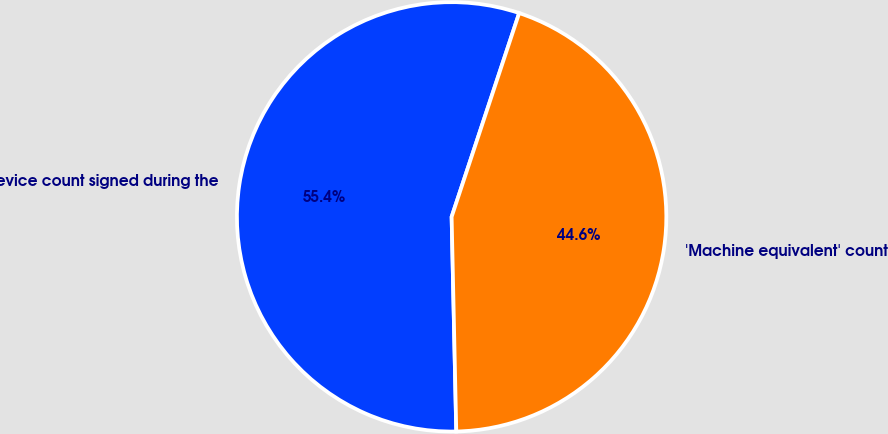<chart> <loc_0><loc_0><loc_500><loc_500><pie_chart><fcel>Device count signed during the<fcel>'Machine equivalent' count<nl><fcel>55.44%<fcel>44.56%<nl></chart> 